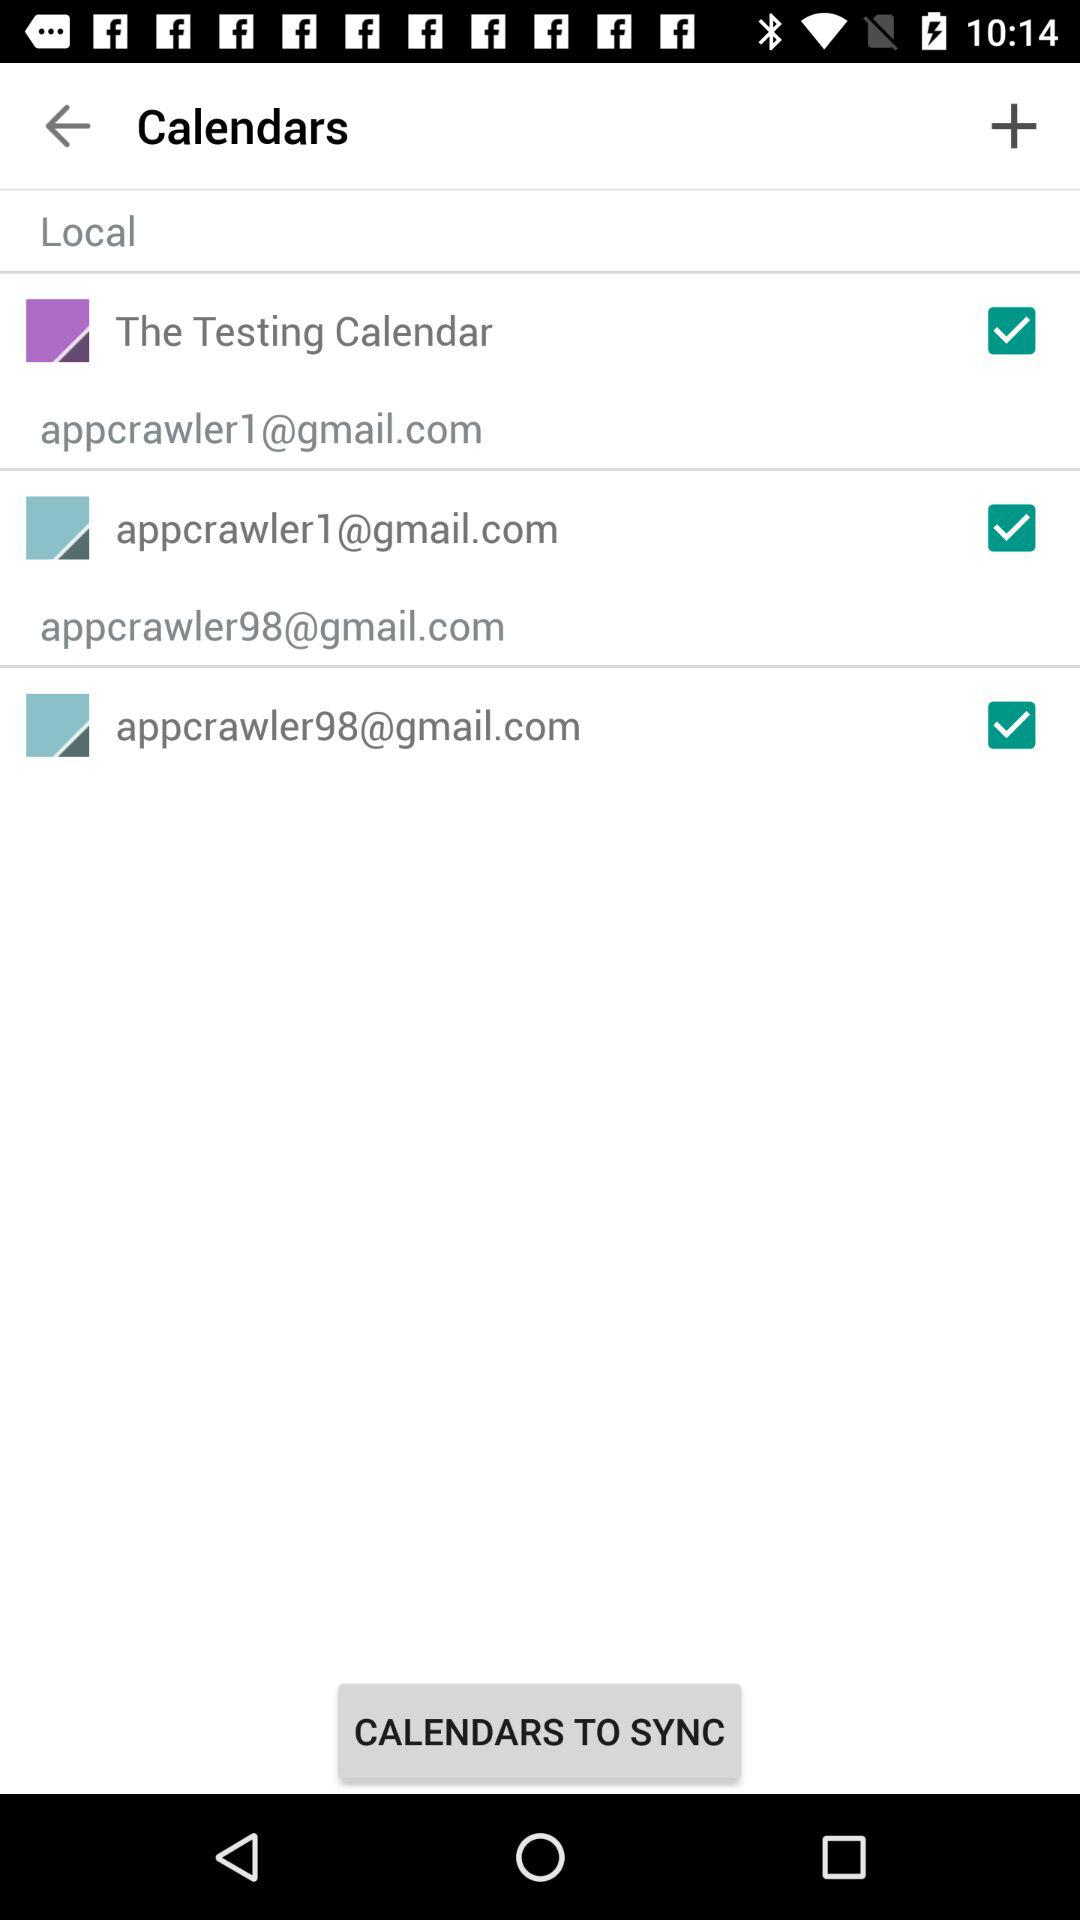What options are selected? The selected options are "The Testing Calendar", "appcrawler1@gmail.com" and "appcrawler98@gmail.com". 